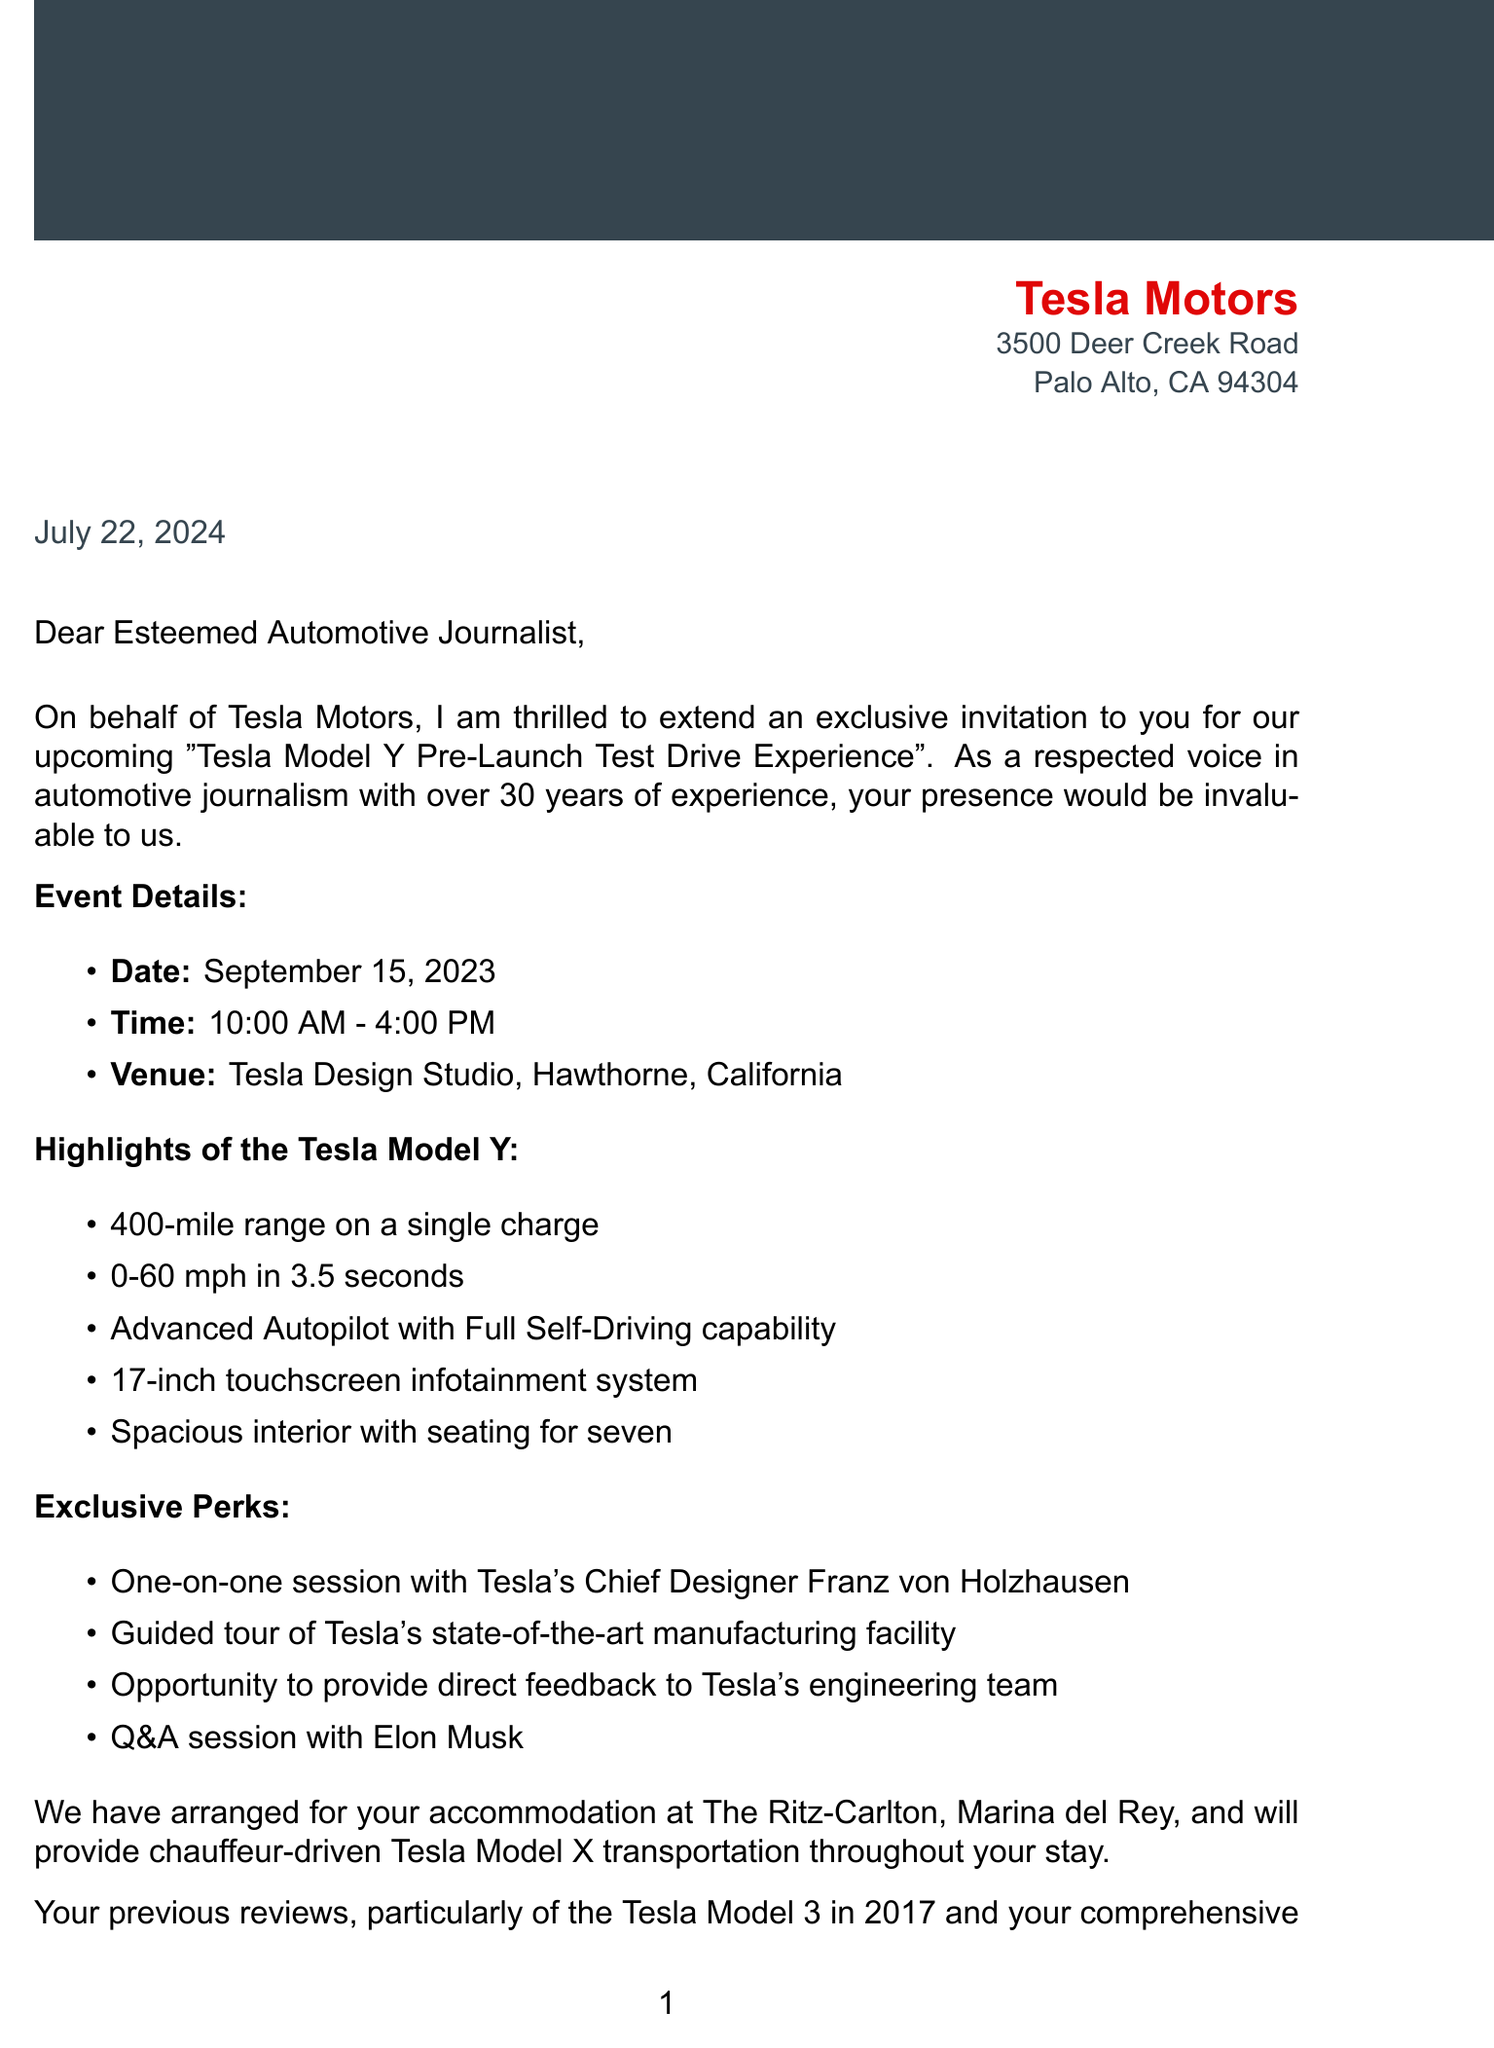What is the name of the event? The name of the event is specifically mentioned in the document as "Tesla Model Y Pre-Launch Test Drive Experience."
Answer: Tesla Model Y Pre-Launch Test Drive Experience When is the test drive scheduled? The scheduled date for the test drive is noted in the document, which is September 15, 2023.
Answer: September 15, 2023 Who is the contact person for the invitation? The contact person is identified in the document as Sarah Johnson, providing her title and contact details.
Answer: Sarah Johnson What is one of the key features of the Tesla Model Y? The document lists several key features, one being that it has a 400-mile range on a single charge.
Answer: 400-mile range on a single charge What hotel has been arranged for accommodation? The name of the hotel where accommodation is arranged is explicitly stated as The Ritz-Carlton, Marina del Rey.
Answer: The Ritz-Carlton, Marina del Rey What time does the event start? The starting time of the event is clearly mentioned in the document as 10:00 AM.
Answer: 10:00 AM What is required by the RSVP deadline? The document mentions a specific date by which the RSVP is required, which is August 31, 2023.
Answer: August 31, 2023 What exclusive session is offered during the event? The document highlights that there will be a one-on-one session with Tesla's Chief Designer, which is an exclusive perk of the invitation.
Answer: One-on-one session with Tesla's Chief Designer What is the purpose of the event as described in the invitation? The purpose of the event as articulated in the invitation revolves around allowing participants to experience the new electric vehicle and contribute to Tesla's mission.
Answer: Accelerating the world's transition to sustainable energy 